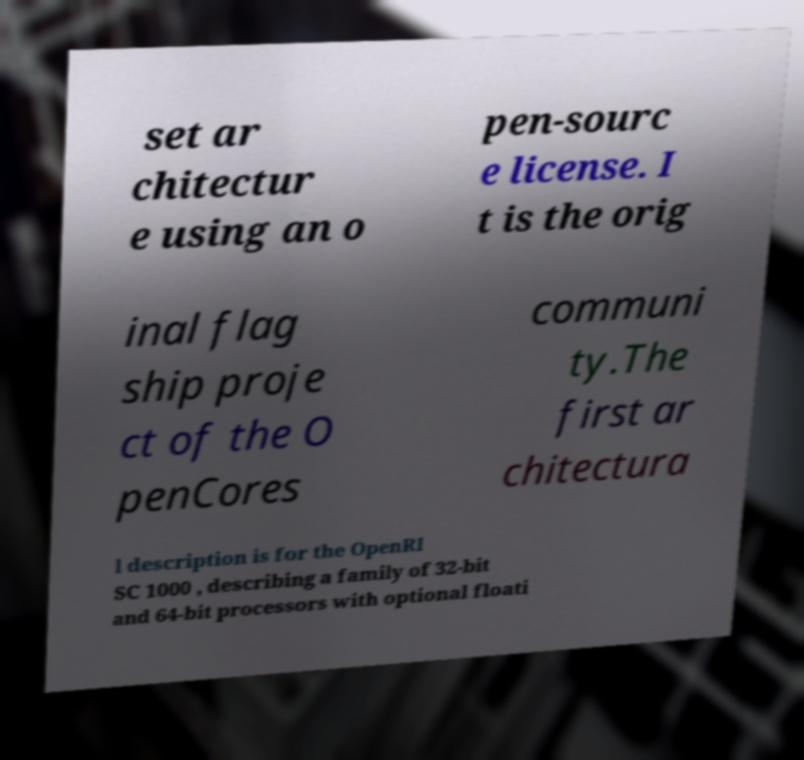There's text embedded in this image that I need extracted. Can you transcribe it verbatim? set ar chitectur e using an o pen-sourc e license. I t is the orig inal flag ship proje ct of the O penCores communi ty.The first ar chitectura l description is for the OpenRI SC 1000 , describing a family of 32-bit and 64-bit processors with optional floati 